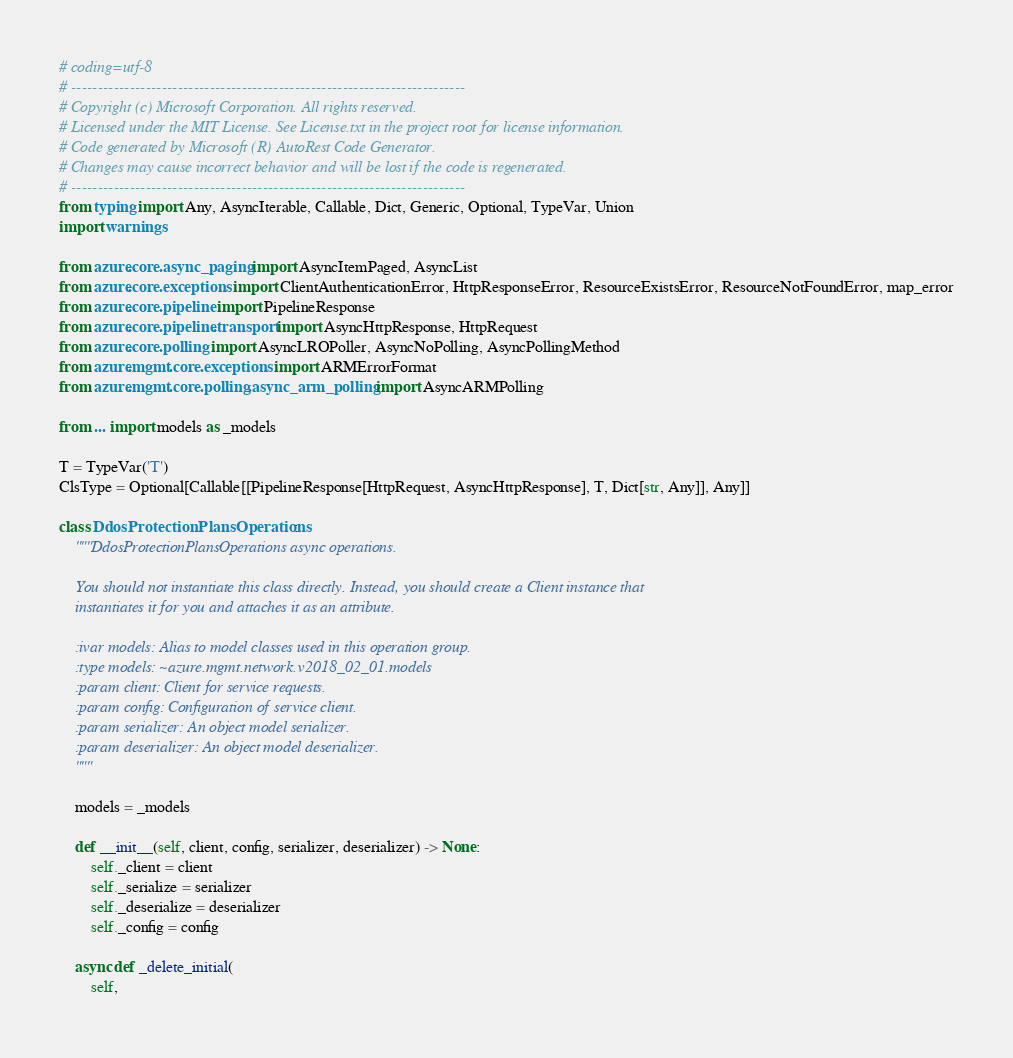Convert code to text. <code><loc_0><loc_0><loc_500><loc_500><_Python_># coding=utf-8
# --------------------------------------------------------------------------
# Copyright (c) Microsoft Corporation. All rights reserved.
# Licensed under the MIT License. See License.txt in the project root for license information.
# Code generated by Microsoft (R) AutoRest Code Generator.
# Changes may cause incorrect behavior and will be lost if the code is regenerated.
# --------------------------------------------------------------------------
from typing import Any, AsyncIterable, Callable, Dict, Generic, Optional, TypeVar, Union
import warnings

from azure.core.async_paging import AsyncItemPaged, AsyncList
from azure.core.exceptions import ClientAuthenticationError, HttpResponseError, ResourceExistsError, ResourceNotFoundError, map_error
from azure.core.pipeline import PipelineResponse
from azure.core.pipeline.transport import AsyncHttpResponse, HttpRequest
from azure.core.polling import AsyncLROPoller, AsyncNoPolling, AsyncPollingMethod
from azure.mgmt.core.exceptions import ARMErrorFormat
from azure.mgmt.core.polling.async_arm_polling import AsyncARMPolling

from ... import models as _models

T = TypeVar('T')
ClsType = Optional[Callable[[PipelineResponse[HttpRequest, AsyncHttpResponse], T, Dict[str, Any]], Any]]

class DdosProtectionPlansOperations:
    """DdosProtectionPlansOperations async operations.

    You should not instantiate this class directly. Instead, you should create a Client instance that
    instantiates it for you and attaches it as an attribute.

    :ivar models: Alias to model classes used in this operation group.
    :type models: ~azure.mgmt.network.v2018_02_01.models
    :param client: Client for service requests.
    :param config: Configuration of service client.
    :param serializer: An object model serializer.
    :param deserializer: An object model deserializer.
    """

    models = _models

    def __init__(self, client, config, serializer, deserializer) -> None:
        self._client = client
        self._serialize = serializer
        self._deserialize = deserializer
        self._config = config

    async def _delete_initial(
        self,</code> 